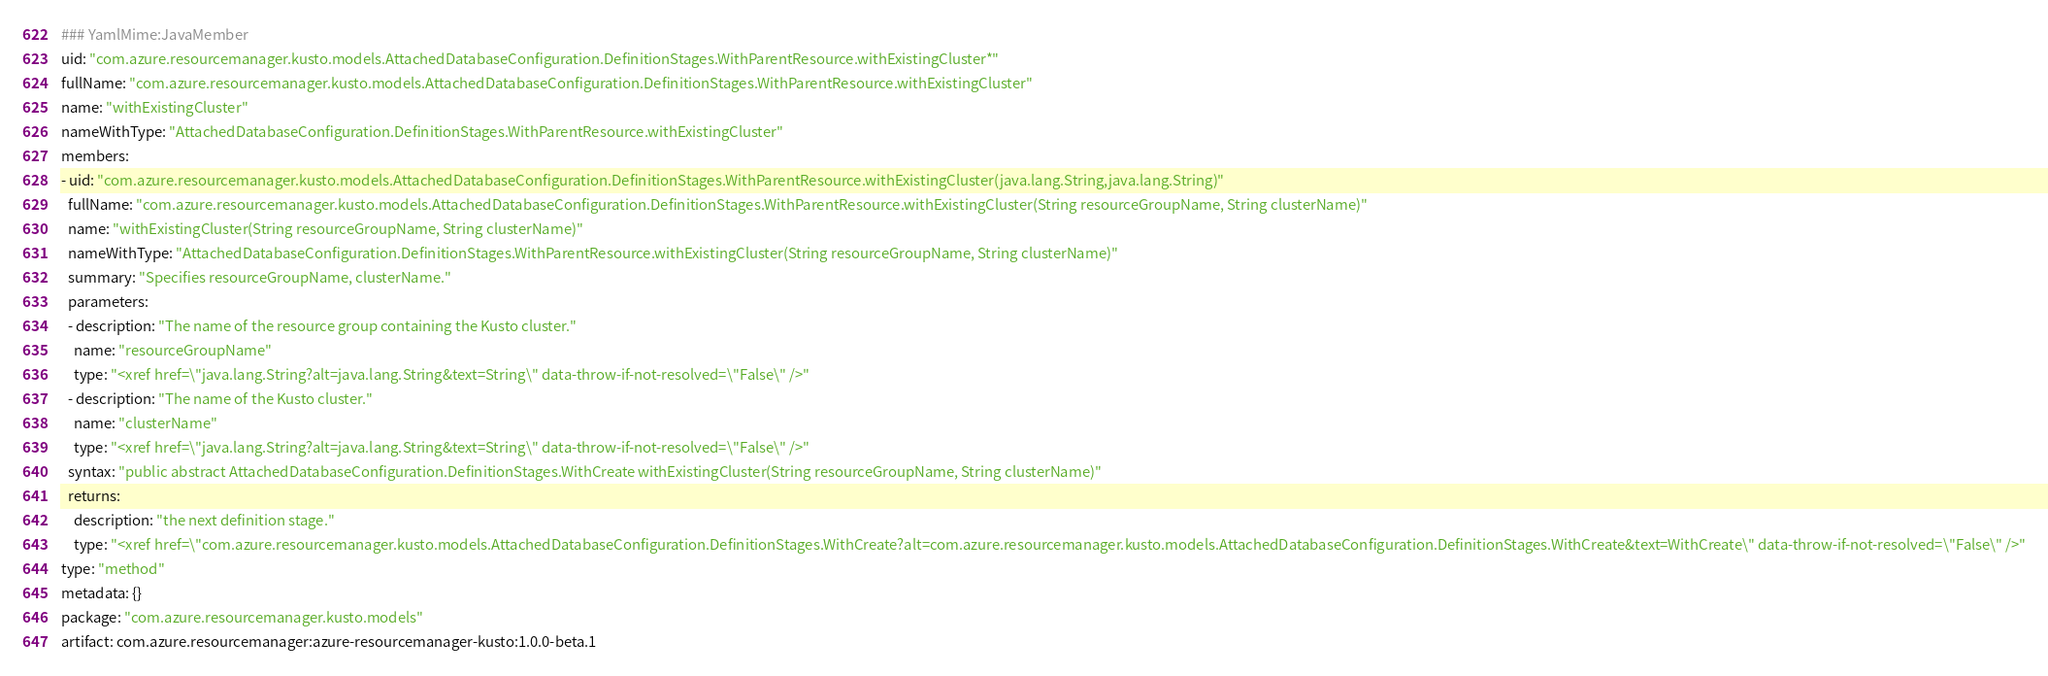<code> <loc_0><loc_0><loc_500><loc_500><_YAML_>### YamlMime:JavaMember
uid: "com.azure.resourcemanager.kusto.models.AttachedDatabaseConfiguration.DefinitionStages.WithParentResource.withExistingCluster*"
fullName: "com.azure.resourcemanager.kusto.models.AttachedDatabaseConfiguration.DefinitionStages.WithParentResource.withExistingCluster"
name: "withExistingCluster"
nameWithType: "AttachedDatabaseConfiguration.DefinitionStages.WithParentResource.withExistingCluster"
members:
- uid: "com.azure.resourcemanager.kusto.models.AttachedDatabaseConfiguration.DefinitionStages.WithParentResource.withExistingCluster(java.lang.String,java.lang.String)"
  fullName: "com.azure.resourcemanager.kusto.models.AttachedDatabaseConfiguration.DefinitionStages.WithParentResource.withExistingCluster(String resourceGroupName, String clusterName)"
  name: "withExistingCluster(String resourceGroupName, String clusterName)"
  nameWithType: "AttachedDatabaseConfiguration.DefinitionStages.WithParentResource.withExistingCluster(String resourceGroupName, String clusterName)"
  summary: "Specifies resourceGroupName, clusterName."
  parameters:
  - description: "The name of the resource group containing the Kusto cluster."
    name: "resourceGroupName"
    type: "<xref href=\"java.lang.String?alt=java.lang.String&text=String\" data-throw-if-not-resolved=\"False\" />"
  - description: "The name of the Kusto cluster."
    name: "clusterName"
    type: "<xref href=\"java.lang.String?alt=java.lang.String&text=String\" data-throw-if-not-resolved=\"False\" />"
  syntax: "public abstract AttachedDatabaseConfiguration.DefinitionStages.WithCreate withExistingCluster(String resourceGroupName, String clusterName)"
  returns:
    description: "the next definition stage."
    type: "<xref href=\"com.azure.resourcemanager.kusto.models.AttachedDatabaseConfiguration.DefinitionStages.WithCreate?alt=com.azure.resourcemanager.kusto.models.AttachedDatabaseConfiguration.DefinitionStages.WithCreate&text=WithCreate\" data-throw-if-not-resolved=\"False\" />"
type: "method"
metadata: {}
package: "com.azure.resourcemanager.kusto.models"
artifact: com.azure.resourcemanager:azure-resourcemanager-kusto:1.0.0-beta.1
</code> 